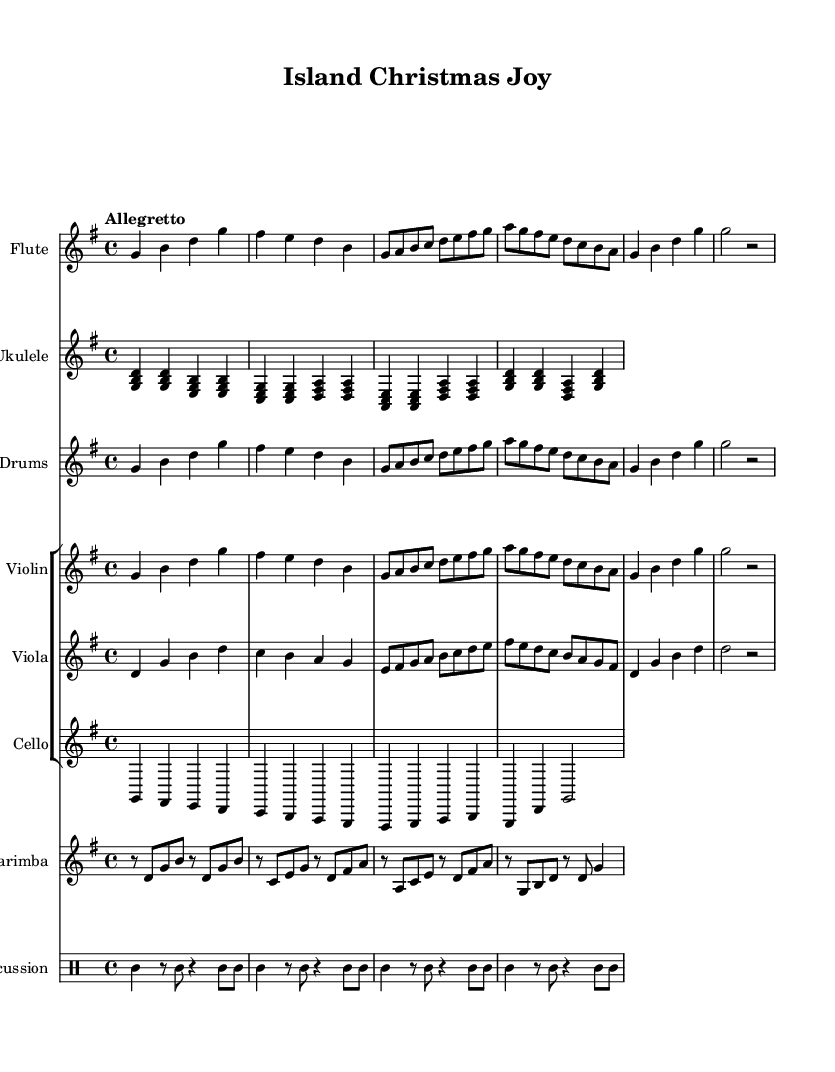What is the key signature of this music? The key signature is G major, which has one sharp (F#).
Answer: G major What is the time signature of this music? The time signature is 4/4, meaning there are four beats in each measure.
Answer: 4/4 What is the tempo marking for this music? The tempo marking is "Allegretto," indicating a moderately fast pace.
Answer: Allegretto How many instruments are featured in this score? There are six instrumental parts: Flute, Ukulele, Steel Drums, Violin, Viola, Cello, Marimba, and Percussion.
Answer: Eight instruments What is the rhythmic pattern primarily used in the percussion section? The percussion section primarily uses a tambourine with consistent eighth and quarter notes throughout the measures.
Answer: Tambourine rhythm How does the melody in the Flute compare to the melody in the Violin? The melody in the Flute and Violin is identical for the first few measures but can have slight variations as they continue, supporting a rich texture in the orchestration.
Answer: Similar melody 